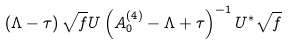Convert formula to latex. <formula><loc_0><loc_0><loc_500><loc_500>( \Lambda - \tau ) \, \sqrt { f } U \left ( A _ { 0 } ^ { ( 4 ) } - \Lambda + \tau \right ) ^ { - 1 } U ^ { \ast } \sqrt { f }</formula> 